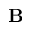<formula> <loc_0><loc_0><loc_500><loc_500>{ B }</formula> 